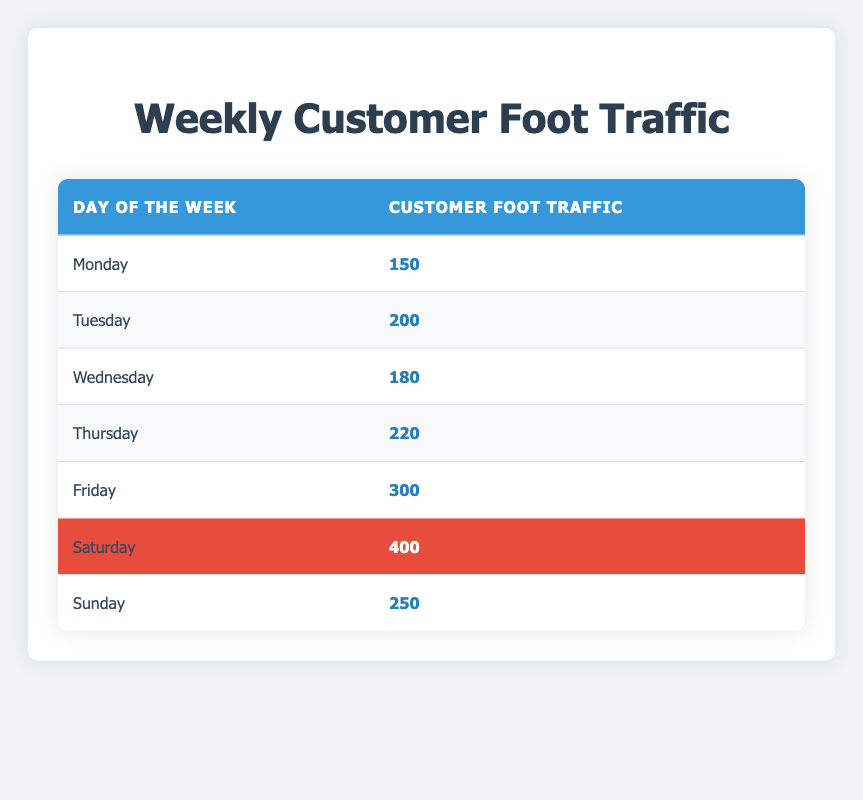What day had the highest customer foot traffic? By looking at the foot traffic values in the table, Saturday has the highest value of 400.
Answer: Saturday What was the foot traffic on Friday? The table shows that the foot traffic on Friday was 300.
Answer: 300 Which day experienced the least foot traffic? From the table, Monday had the lowest foot traffic with a value of 150.
Answer: Monday What is the total customer foot traffic from Monday to Friday? To find the total from Monday to Friday, we add their foot traffic: 150 + 200 + 180 + 220 + 300 = 1050.
Answer: 1050 Is the foot traffic on Sunday greater than that on Tuesday? Comparing the two values, Sunday had 250 and Tuesday had 200. Since 250 is greater than 200, the answer is yes.
Answer: Yes What is the average customer foot traffic for the entire week? First, we sum all daily foot traffic values: 150 + 200 + 180 + 220 + 300 + 400 + 250 = 1680. Then divide by 7 (the number of days): 1680 / 7 = 240.
Answer: 240 Did the foot traffic on Thursday exceed that on Wednesday? Thursday had 220 and Wednesday had 180. Since 220 is more than 180, the answer is yes.
Answer: Yes What is the difference in foot traffic between Saturday and Sunday? Saturday had 400 and Sunday had 250. The difference is 400 - 250 = 150.
Answer: 150 How does the foot traffic on Tuesday compare to the average of the week? The average foot traffic is 240, and Tuesday’s foot traffic is 200, which is less than the average. Thus, the answer is no.
Answer: No 